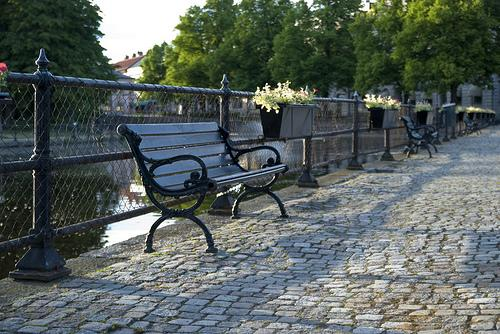What is the sidewalk made of? Please explain your reasoning. cobblestones. The sidewalk has cobblestones. 